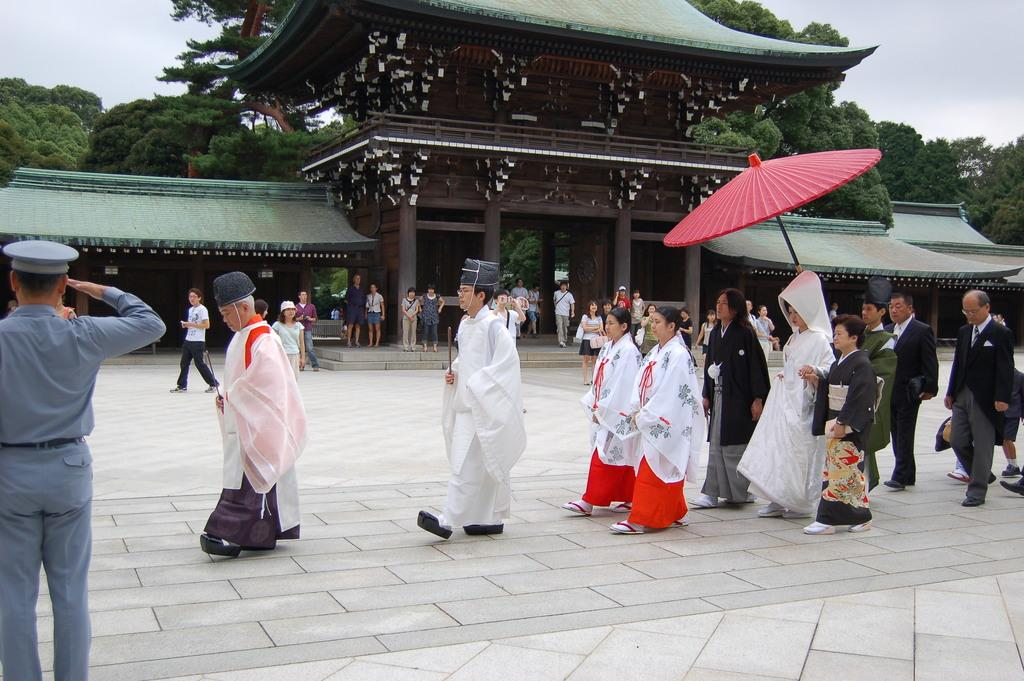What location is depicted in the image? The image depicts Meiji-shrine. What are the people in the image doing? There are persons walking through the floor in the image. What can be seen in the background of the image? There are trees in the background of the image. What type of sugar can be seen falling from the sky in the image? There is no sugar falling from the sky in the image; it depicts Meiji-shrine with people walking and trees in the background. Can you see a boy playing with a toy in the image? There is no boy or toy present in the image. 